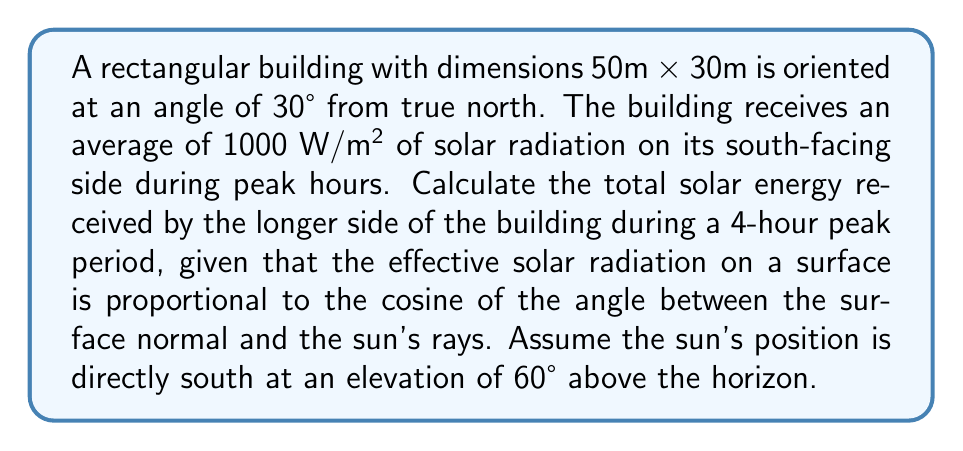Teach me how to tackle this problem. 1. First, we need to determine which side of the building is receiving the most direct sunlight. The longer side (50m) will be more exposed to the south.

2. Calculate the angle between the building's longer side and the sun's rays:
   - Building angle from north: 30°
   - Sun's position: directly south (180° from north)
   - Angle between building and sun: $180° - 30° = 150°$

3. Calculate the effective solar radiation using the cosine function:
   $E_{\text{eff}} = E_{\text{max}} \cdot \cos(\theta)$
   Where $\theta$ is the angle between the surface normal and the sun's rays.
   
   The surface normal is perpendicular to the building's side, so:
   $\theta = 150° - 90° = 60°$

   $E_{\text{eff}} = 1000 \text{ W/m²} \cdot \cos(60°) = 500 \text{ W/m²}$

4. Calculate the area of the longer side of the building:
   $A = 50\text{ m} \cdot 30\text{ m} = 1500\text{ m²}$

5. Calculate the total energy received during the 4-hour peak period:
   $E_{\text{total}} = E_{\text{eff}} \cdot A \cdot t$
   Where $t$ is the time in seconds (4 hours = 14400 seconds)

   $E_{\text{total}} = 500 \text{ W/m²} \cdot 1500\text{ m²} \cdot 14400\text{ s}$
   $E_{\text{total}} = 10,800,000,000 \text{ J} = 10.8 \text{ GJ}$
Answer: 10.8 GJ 